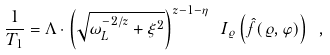Convert formula to latex. <formula><loc_0><loc_0><loc_500><loc_500>\frac { 1 } { T _ { 1 } } = \Lambda \cdot \left ( \sqrt { \omega _ { L } ^ { - 2 / z } + \xi ^ { 2 } } \right ) ^ { z - 1 - \eta } \ I _ { \varrho } \left ( \hat { f } ( \varrho , \varphi ) \right ) \ ,</formula> 